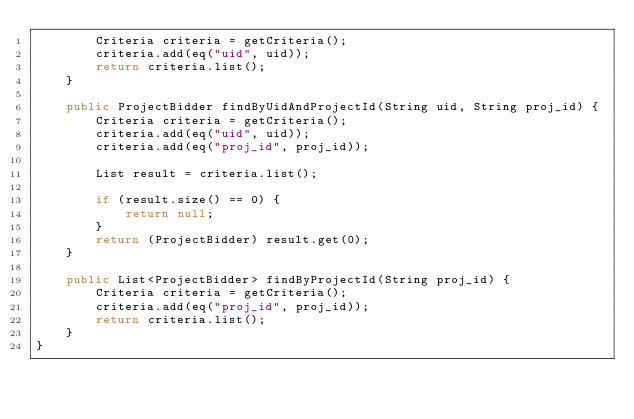Convert code to text. <code><loc_0><loc_0><loc_500><loc_500><_Java_>        Criteria criteria = getCriteria();
        criteria.add(eq("uid", uid));
        return criteria.list();
    }

    public ProjectBidder findByUidAndProjectId(String uid, String proj_id) {
        Criteria criteria = getCriteria();
        criteria.add(eq("uid", uid));
        criteria.add(eq("proj_id", proj_id));

        List result = criteria.list();

        if (result.size() == 0) {
            return null;
        }
        return (ProjectBidder) result.get(0);
    }

    public List<ProjectBidder> findByProjectId(String proj_id) {
        Criteria criteria = getCriteria();
        criteria.add(eq("proj_id", proj_id));
        return criteria.list();
    }
}</code> 